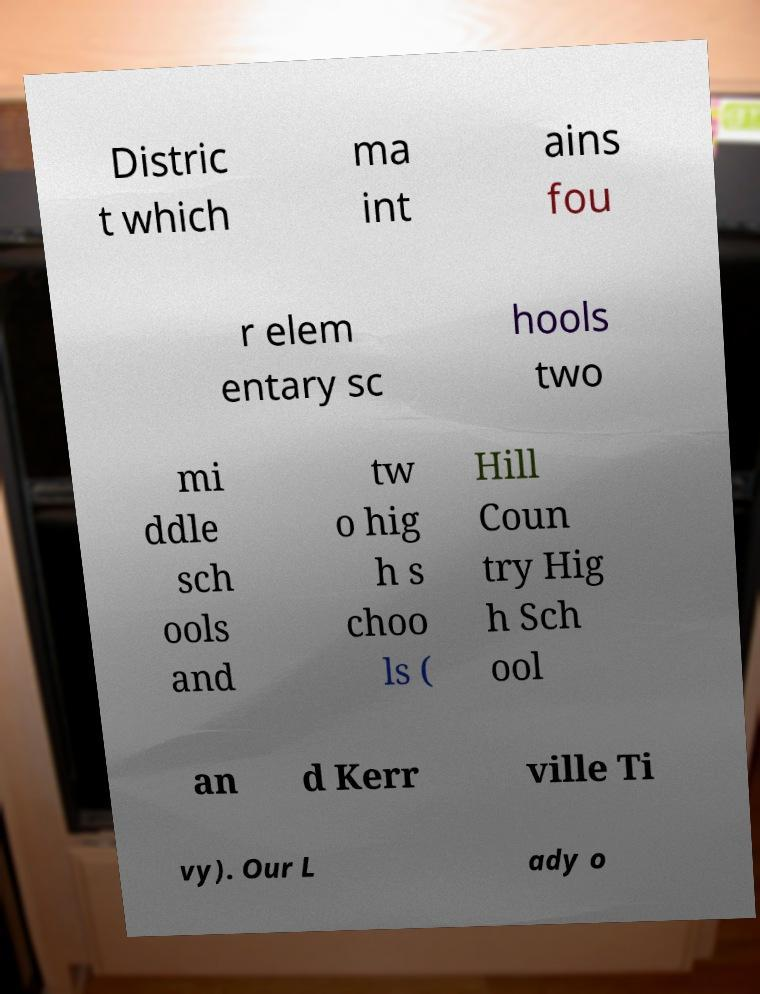Can you read and provide the text displayed in the image?This photo seems to have some interesting text. Can you extract and type it out for me? Distric t which ma int ains fou r elem entary sc hools two mi ddle sch ools and tw o hig h s choo ls ( Hill Coun try Hig h Sch ool an d Kerr ville Ti vy). Our L ady o 